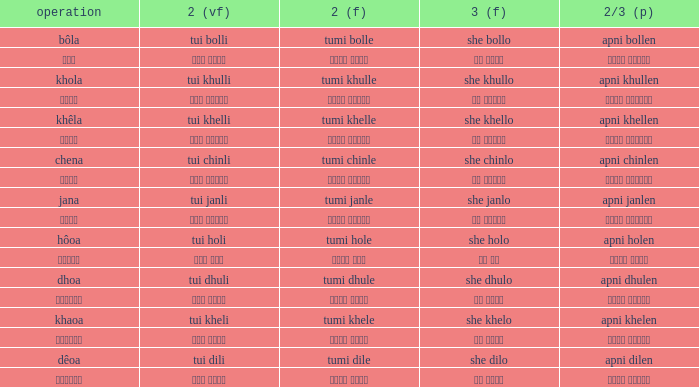I'm looking to parse the entire table for insights. Could you assist me with that? {'header': ['operation', '2 (vf)', '2 (f)', '3 (f)', '2/3 (p)'], 'rows': [['bôla', 'tui bolli', 'tumi bolle', 'she bollo', 'apni bollen'], ['বলা', 'তুই বললি', 'তুমি বললে', 'সে বললো', 'আপনি বললেন'], ['khola', 'tui khulli', 'tumi khulle', 'she khullo', 'apni khullen'], ['খোলা', 'তুই খুললি', 'তুমি খুললে', 'সে খুললো', 'আপনি খুললেন'], ['khêla', 'tui khelli', 'tumi khelle', 'she khello', 'apni khellen'], ['খেলে', 'তুই খেললি', 'তুমি খেললে', 'সে খেললো', 'আপনি খেললেন'], ['chena', 'tui chinli', 'tumi chinle', 'she chinlo', 'apni chinlen'], ['চেনা', 'তুই চিনলি', 'তুমি চিনলে', 'সে চিনলো', 'আপনি চিনলেন'], ['jana', 'tui janli', 'tumi janle', 'she janlo', 'apni janlen'], ['জানা', 'তুই জানলি', 'তুমি জানলে', 'সে জানলে', 'আপনি জানলেন'], ['hôoa', 'tui holi', 'tumi hole', 'she holo', 'apni holen'], ['হওয়া', 'তুই হলি', 'তুমি হলে', 'সে হল', 'আপনি হলেন'], ['dhoa', 'tui dhuli', 'tumi dhule', 'she dhulo', 'apni dhulen'], ['ধোওয়া', 'তুই ধুলি', 'তুমি ধুলে', 'সে ধুলো', 'আপনি ধুলেন'], ['khaoa', 'tui kheli', 'tumi khele', 'she khelo', 'apni khelen'], ['খাওয়া', 'তুই খেলি', 'তুমি খেলে', 'সে খেলো', 'আপনি খেলেন'], ['dêoa', 'tui dili', 'tumi dile', 'she dilo', 'apni dilen'], ['দেওয়া', 'তুই দিলি', 'তুমি দিলে', 'সে দিলো', 'আপনি দিলেন']]} What is the 2(vf) for তুমি বললে? তুই বললি. 